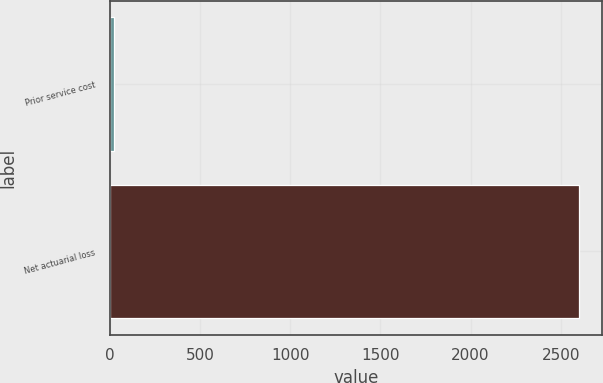Convert chart to OTSL. <chart><loc_0><loc_0><loc_500><loc_500><bar_chart><fcel>Prior service cost<fcel>Net actuarial loss<nl><fcel>23<fcel>2599<nl></chart> 